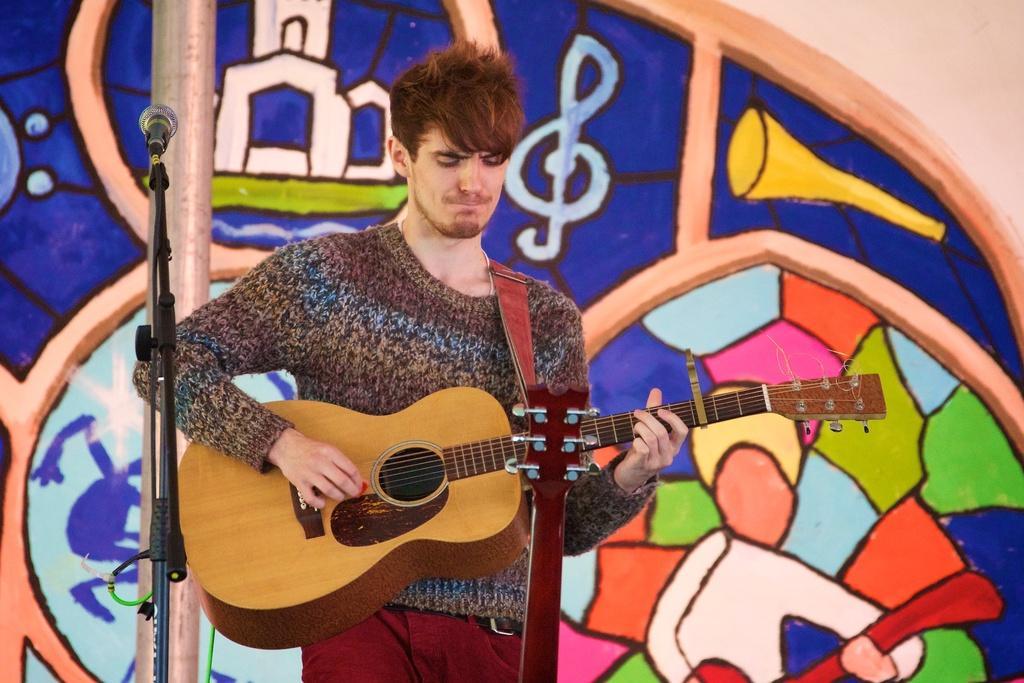Could you give a brief overview of what you see in this image? In this image, human is playing a guitar in-front of mic and stand ,wire. At background, we can see a colorful wall. 